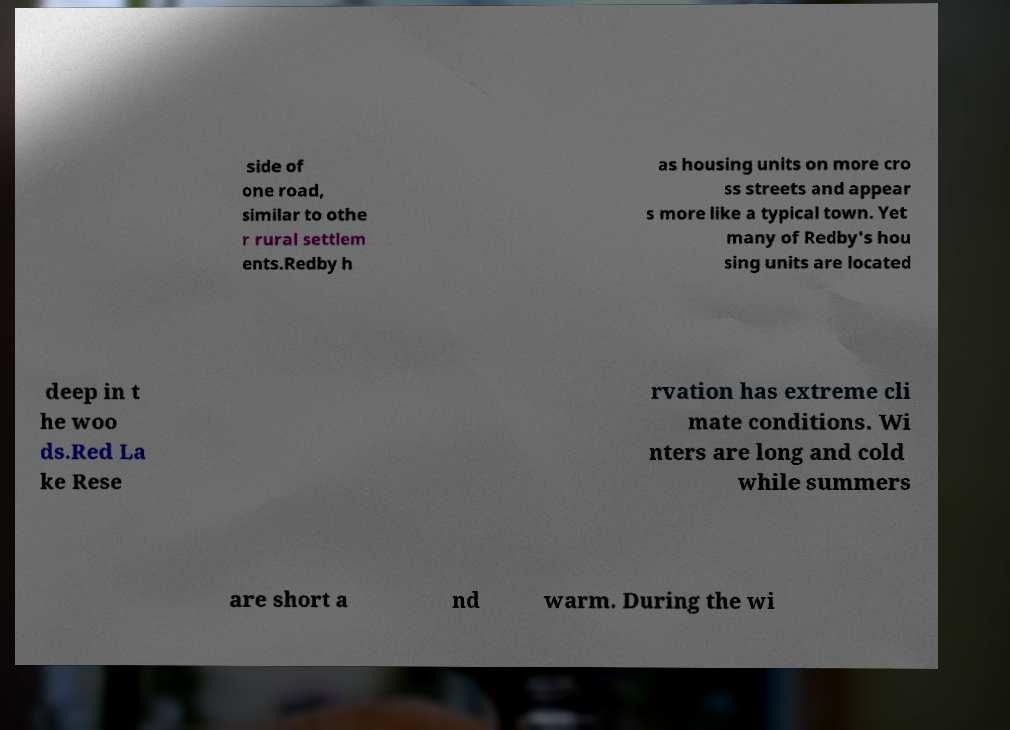There's text embedded in this image that I need extracted. Can you transcribe it verbatim? side of one road, similar to othe r rural settlem ents.Redby h as housing units on more cro ss streets and appear s more like a typical town. Yet many of Redby's hou sing units are located deep in t he woo ds.Red La ke Rese rvation has extreme cli mate conditions. Wi nters are long and cold while summers are short a nd warm. During the wi 